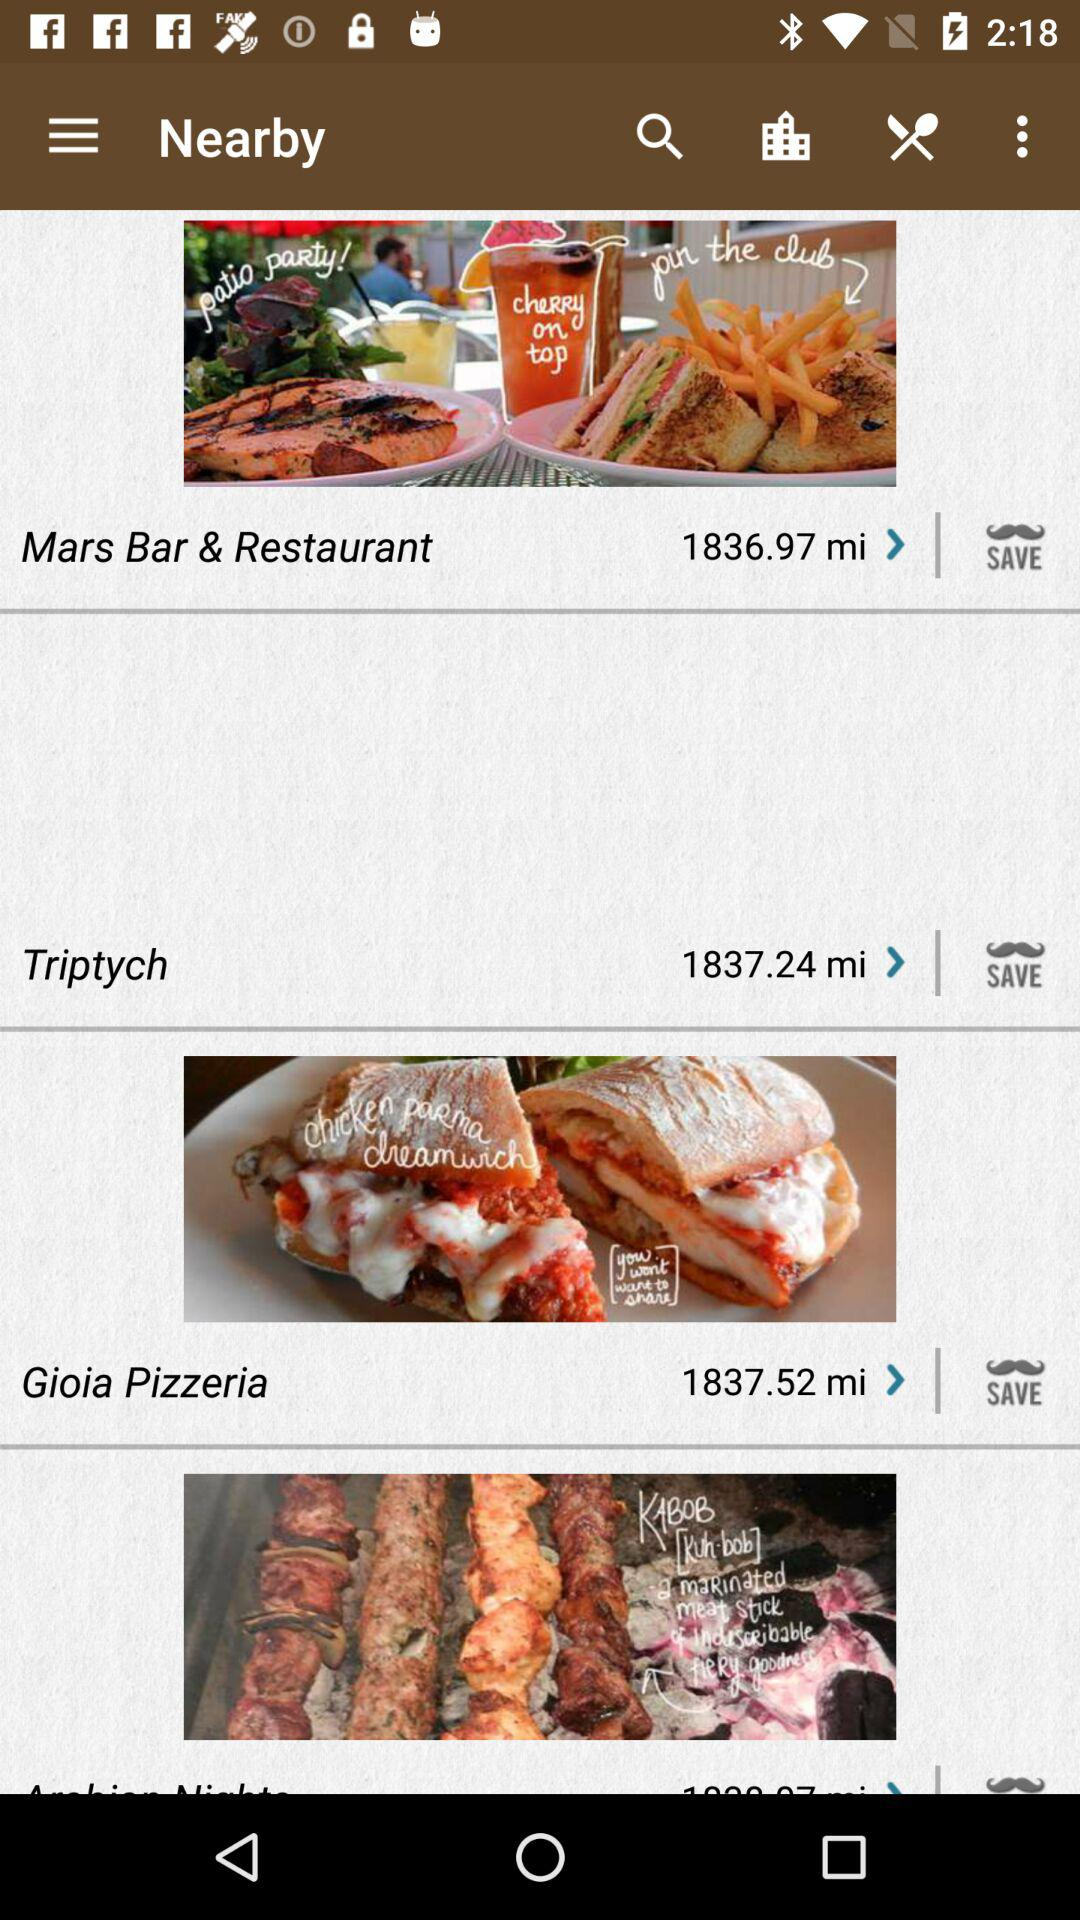What is the distance between Mars Bar & Restaurant and my location? The distance is 1836.97 miles. 